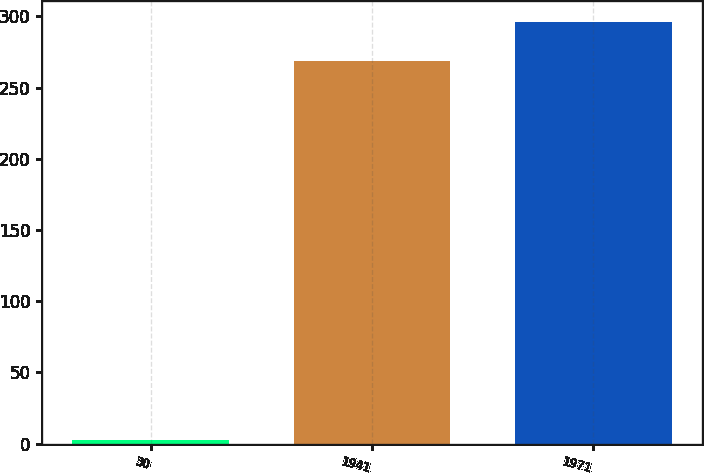Convert chart to OTSL. <chart><loc_0><loc_0><loc_500><loc_500><bar_chart><fcel>30<fcel>1941<fcel>1971<nl><fcel>2.5<fcel>269<fcel>295.9<nl></chart> 